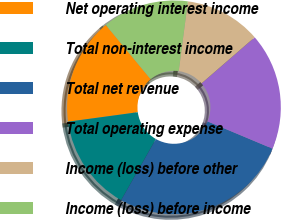Convert chart to OTSL. <chart><loc_0><loc_0><loc_500><loc_500><pie_chart><fcel>Net operating interest income<fcel>Total non-interest income<fcel>Total net revenue<fcel>Total operating expense<fcel>Income (loss) before other<fcel>Income (loss) before income<nl><fcel>16.15%<fcel>14.62%<fcel>26.91%<fcel>17.69%<fcel>11.55%<fcel>13.08%<nl></chart> 